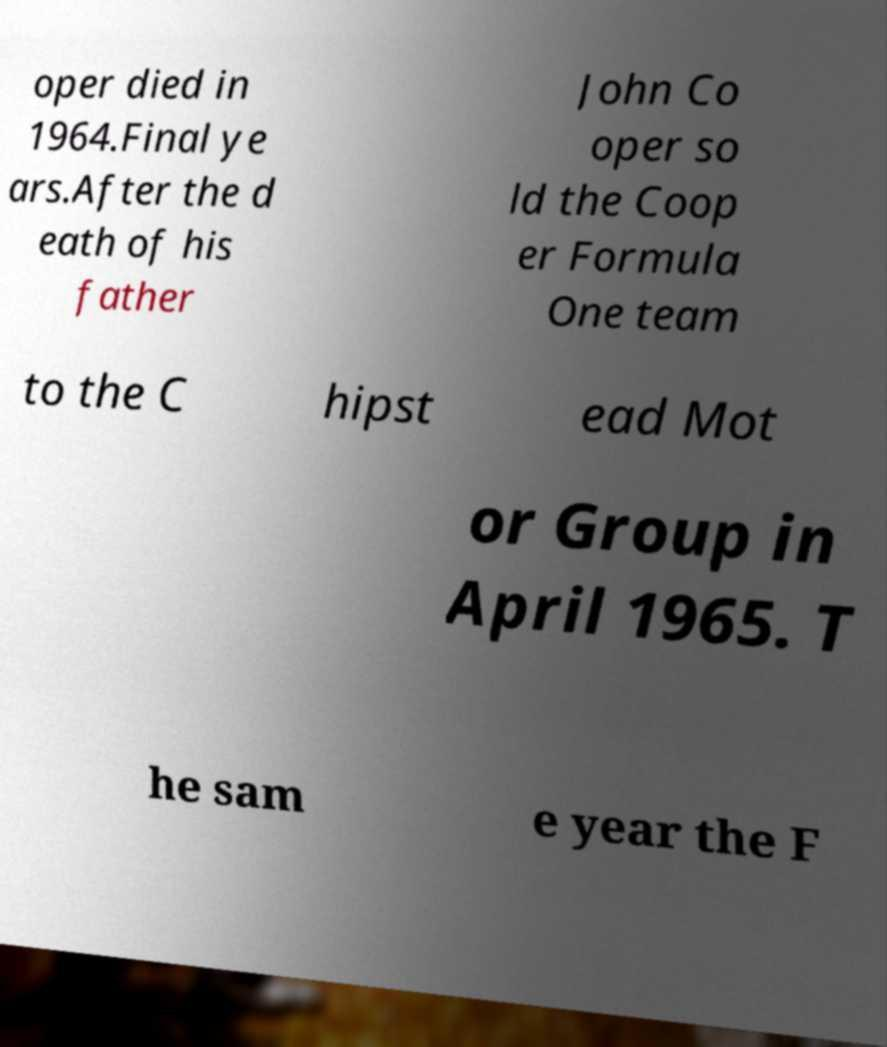Can you accurately transcribe the text from the provided image for me? oper died in 1964.Final ye ars.After the d eath of his father John Co oper so ld the Coop er Formula One team to the C hipst ead Mot or Group in April 1965. T he sam e year the F 